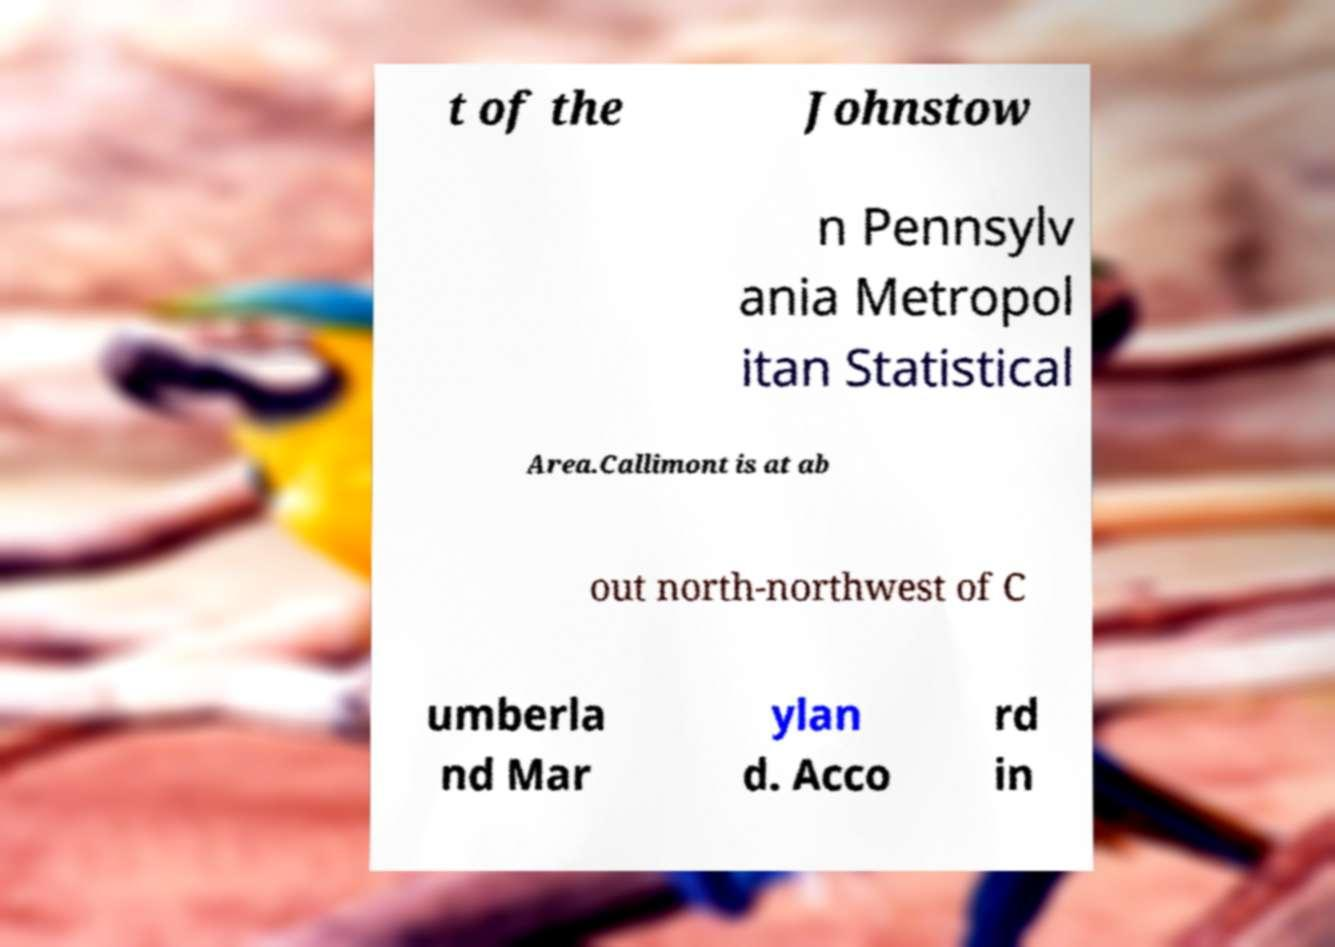What messages or text are displayed in this image? I need them in a readable, typed format. t of the Johnstow n Pennsylv ania Metropol itan Statistical Area.Callimont is at ab out north-northwest of C umberla nd Mar ylan d. Acco rd in 